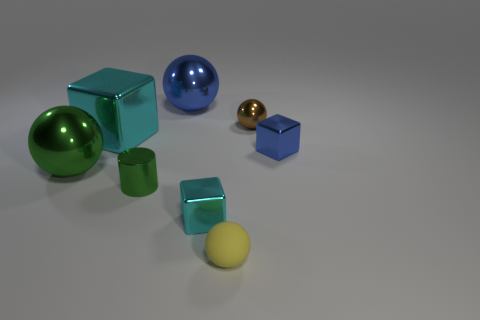There is a yellow sphere that is the same size as the blue shiny cube; what is its material?
Offer a terse response. Rubber. Are there more blue rubber objects than big shiny balls?
Your answer should be compact. No. There is a cyan metallic block behind the ball to the left of the small cylinder; what size is it?
Provide a short and direct response. Large. What shape is the brown metallic object that is the same size as the yellow rubber sphere?
Provide a short and direct response. Sphere. What is the shape of the blue thing on the left side of the small brown object that is to the left of the metallic cube on the right side of the tiny yellow ball?
Your response must be concise. Sphere. There is a block behind the small blue metal cube; does it have the same color as the tiny metallic block on the left side of the small matte thing?
Provide a short and direct response. Yes. How many tiny blue rubber cylinders are there?
Give a very brief answer. 0. Are there any large green metal things behind the matte thing?
Your answer should be compact. Yes. Are the cyan object in front of the tiny green cylinder and the tiny sphere that is to the left of the tiny brown ball made of the same material?
Ensure brevity in your answer.  No. Is the number of tiny blue metal cubes behind the large blue metallic sphere less than the number of brown shiny cubes?
Offer a terse response. No. 